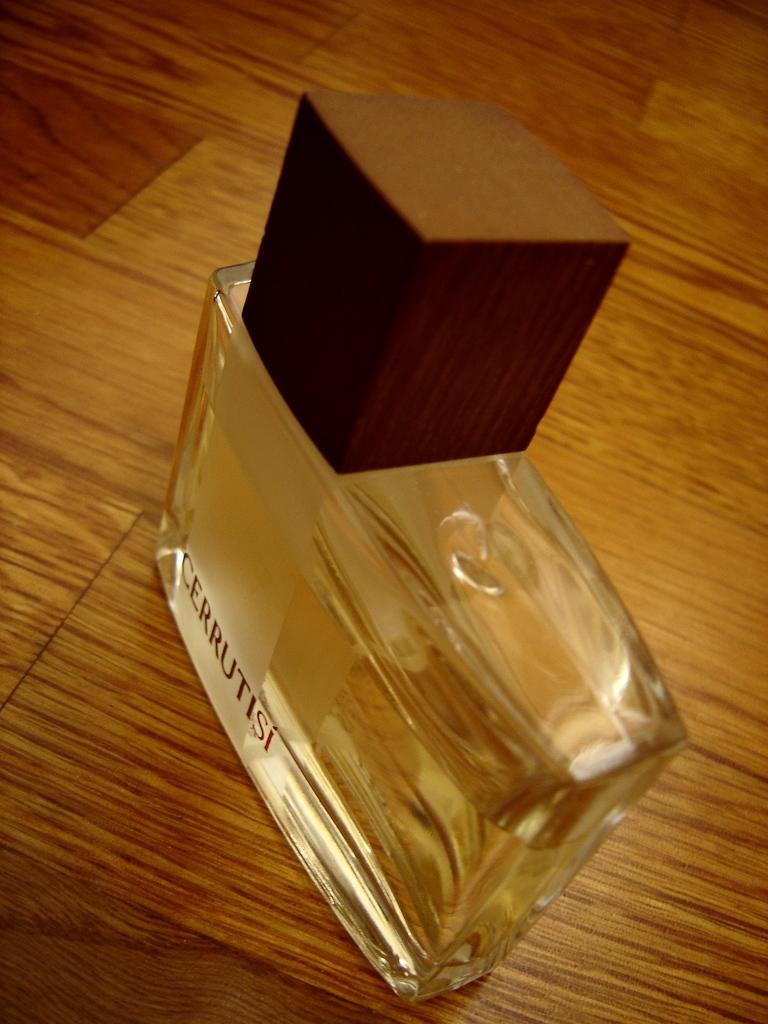<image>
Render a clear and concise summary of the photo. Bottle of Cerrutisi cologne on top of a wooden table. 